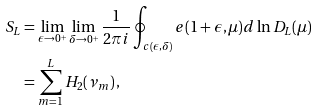Convert formula to latex. <formula><loc_0><loc_0><loc_500><loc_500>S _ { L } & = \lim _ { \epsilon \to 0 ^ { + } } \lim _ { \delta \to 0 ^ { + } } \frac { 1 } { 2 \pi i } \oint _ { c ( \epsilon , \delta ) } e ( 1 + \epsilon , \mu ) d \ln D _ { L } ( \mu ) \\ & = \sum _ { m = 1 } ^ { L } H _ { 2 } ( \nu _ { m } ) \, ,</formula> 